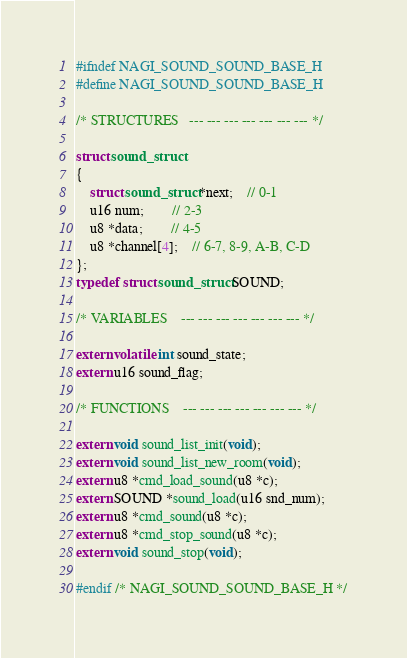<code> <loc_0><loc_0><loc_500><loc_500><_C_>#ifndef NAGI_SOUND_SOUND_BASE_H
#define NAGI_SOUND_SOUND_BASE_H

/* STRUCTURES	---	---	---	---	---	---	--- */

struct sound_struct
{
	struct sound_struct *next;	// 0-1
	u16 num;		// 2-3
	u8 *data;		// 4-5
	u8 *channel[4];	// 6-7, 8-9, A-B, C-D
};
typedef struct sound_struct SOUND;

/* VARIABLES	---	---	---	---	---	---	--- */

extern volatile int sound_state;
extern u16 sound_flag;

/* FUNCTIONS	---	---	---	---	---	---	--- */

extern void sound_list_init(void);
extern void sound_list_new_room(void);
extern u8 *cmd_load_sound(u8 *c);
extern SOUND *sound_load(u16 snd_num);
extern u8 *cmd_sound(u8 *c);
extern u8 *cmd_stop_sound(u8 *c);
extern void sound_stop(void);

#endif /* NAGI_SOUND_SOUND_BASE_H */
</code> 